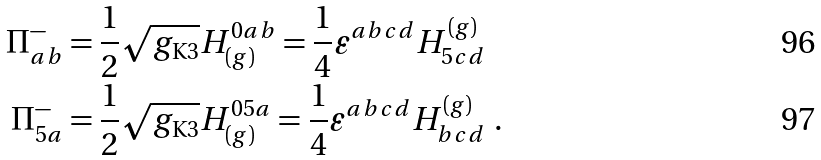<formula> <loc_0><loc_0><loc_500><loc_500>\Pi ^ { - } _ { a b } & = \frac { 1 } { 2 } \sqrt { g _ { \text  K3}} H_{(g)}^{0ab} = \frac{1}{4}\varepsilon^{abcd}H^{(g)}_{5cd}\\ \Pi^{-}_{5a}& =\frac{1}{2} \sqrt{g_{\text  K3}} H_{(g)}^{05a} = \frac{1}{4}\varepsilon^{abcd}H^{(g)}_{bcd} \ .</formula> 